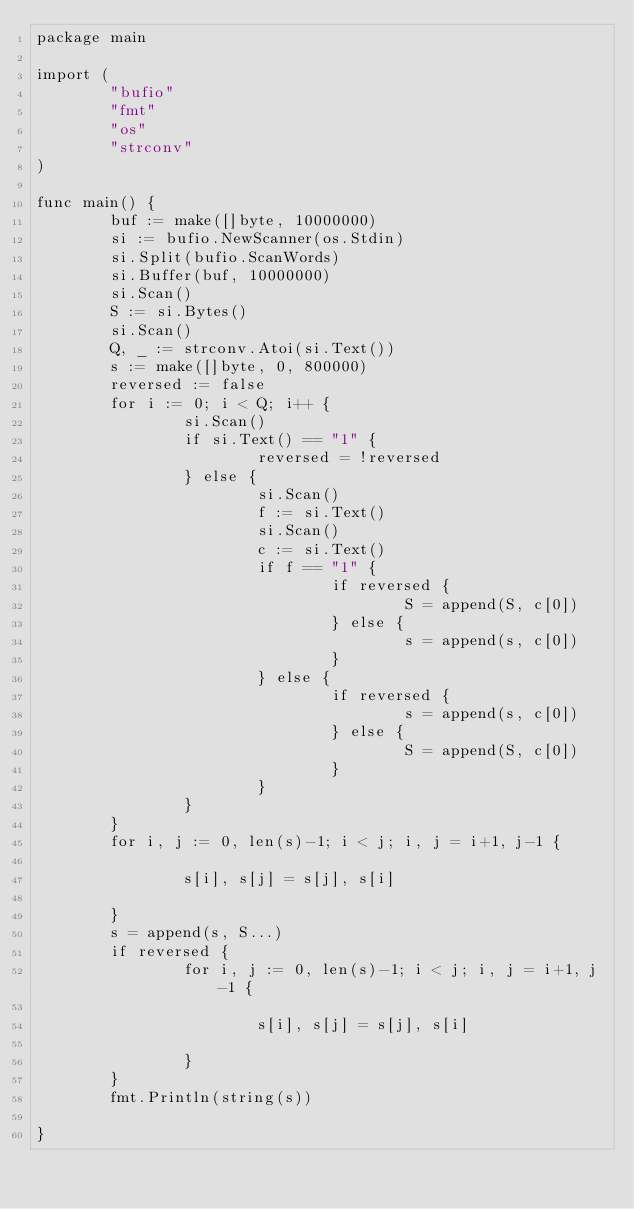<code> <loc_0><loc_0><loc_500><loc_500><_Go_>package main

import (
        "bufio"
        "fmt"
        "os"
        "strconv"
)

func main() {
        buf := make([]byte, 10000000)
        si := bufio.NewScanner(os.Stdin)
        si.Split(bufio.ScanWords)
        si.Buffer(buf, 10000000)
        si.Scan()
        S := si.Bytes()
        si.Scan()
        Q, _ := strconv.Atoi(si.Text())
        s := make([]byte, 0, 800000)
        reversed := false
        for i := 0; i < Q; i++ {
                si.Scan()
                if si.Text() == "1" {
                        reversed = !reversed
                } else {
                        si.Scan()
                        f := si.Text()
                        si.Scan()
                        c := si.Text()
                        if f == "1" {
                                if reversed {
                                        S = append(S, c[0])
                                } else {
                                        s = append(s, c[0])
                                }
                        } else {
                                if reversed {
                                        s = append(s, c[0])
                                } else {
                                        S = append(S, c[0])
                                }
                        }
                }
        }
        for i, j := 0, len(s)-1; i < j; i, j = i+1, j-1 {

                s[i], s[j] = s[j], s[i]

        }
        s = append(s, S...)
        if reversed {
                for i, j := 0, len(s)-1; i < j; i, j = i+1, j-1 {

                        s[i], s[j] = s[j], s[i]

                }
        }
        fmt.Println(string(s))

}</code> 